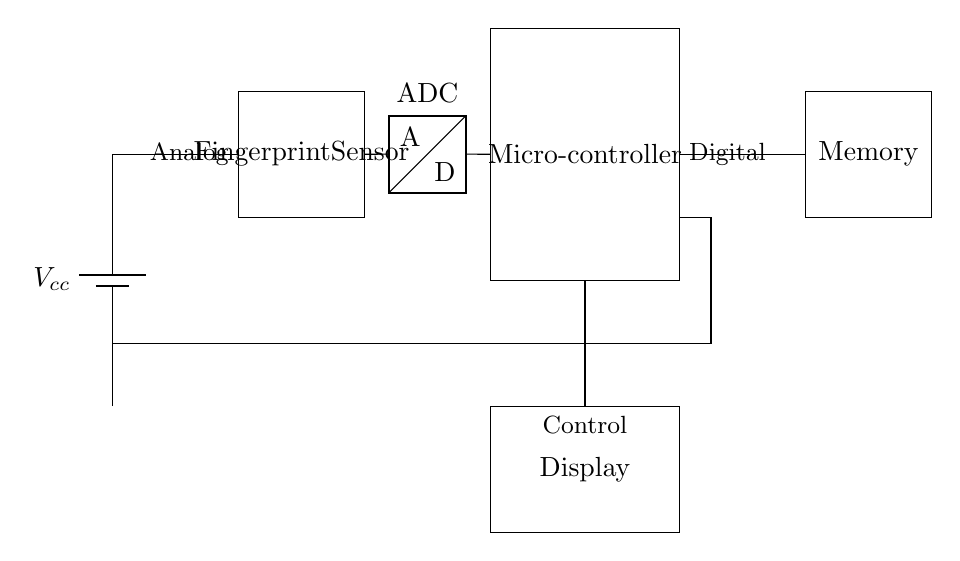What is the main function of the fingerprint sensor? The fingerprint sensor's main function is to capture and convert fingerprint images into digital data for recognition.
Answer: Capture and convert fingerprint images What component is connected to the ADC? The component connected to the ADC is the fingerprint sensor, as indicated by the direct connection in the circuit diagram.
Answer: Fingerprint sensor What type of data does the microcontroller process? The microcontroller processes digital data, as stated in the diagram where it is labeled as such, indicating its role in handling the output from the ADC.
Answer: Digital data How is the fingerprint sensor powered? The fingerprint sensor is powered by the battery labeled as Vcc, which provides the necessary voltage for its operation.
Answer: Vcc What is the purpose of the memory in this circuit? The memory stores the processed fingerprint data and any necessary information for recognition, which is crucial for security functionality.
Answer: Store fingerprint data How does the display get its control signal? The display receives its control signal from the microcontroller, highlighted by the direct line connecting it to the microcontroller that handles the output.
Answer: Microcontroller Which component is responsible for converting analog signals to digital? The component responsible for converting analog signals to digital in this circuit is the ADC, as identified by its specific label in the diagram.
Answer: ADC 